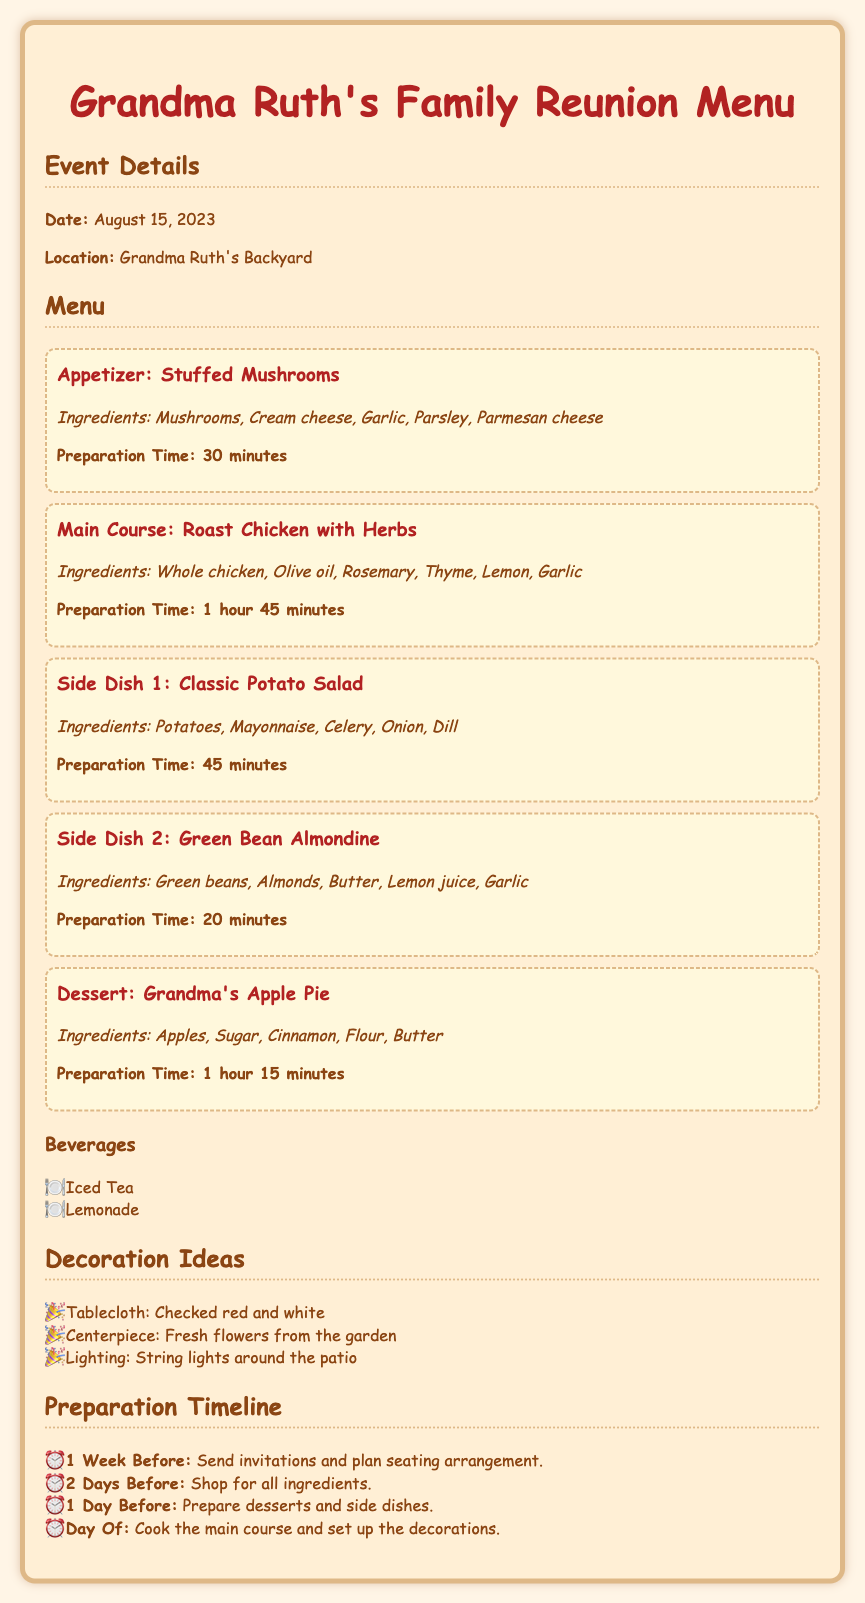What is the date of the family reunion? The date can be found in the Event Details section of the document, which states it is August 15, 2023.
Answer: August 15, 2023 Where will the family gathering take place? The location is indicated in the Event Details section, which mentions Grandma Ruth's Backyard.
Answer: Grandma Ruth's Backyard What is one of the ingredients in the Stuffed Mushrooms? The ingredients for Stuffed Mushrooms are listed in the Menu section, including Cream cheese.
Answer: Cream cheese How long does it take to prepare the Roast Chicken with Herbs? The preparation time for the Roast Chicken with Herbs is stated in the Menu section as 1 hour 45 minutes.
Answer: 1 hour 45 minutes What dessert is included in the menu? The dessert is specified in the Menu section as Grandma's Apple Pie.
Answer: Grandma's Apple Pie What type of tablecloth is suggested for decoration? The decoration ideas mention a checked red and white tablecloth.
Answer: Checked red and white When should invitations be sent out? The preparation timeline indicates that invitations should be sent out 1 week before the event.
Answer: 1 week before What lighting feature is mentioned for the decorations? The decoration ideas include string lights around the patio, which enhances the ambiance.
Answer: String lights What is the preparation step mentioned for the day of the event? The preparation timeline states that the main course should be cooked and decorations set up on the day of the event.
Answer: Cook the main course and set up the decorations 